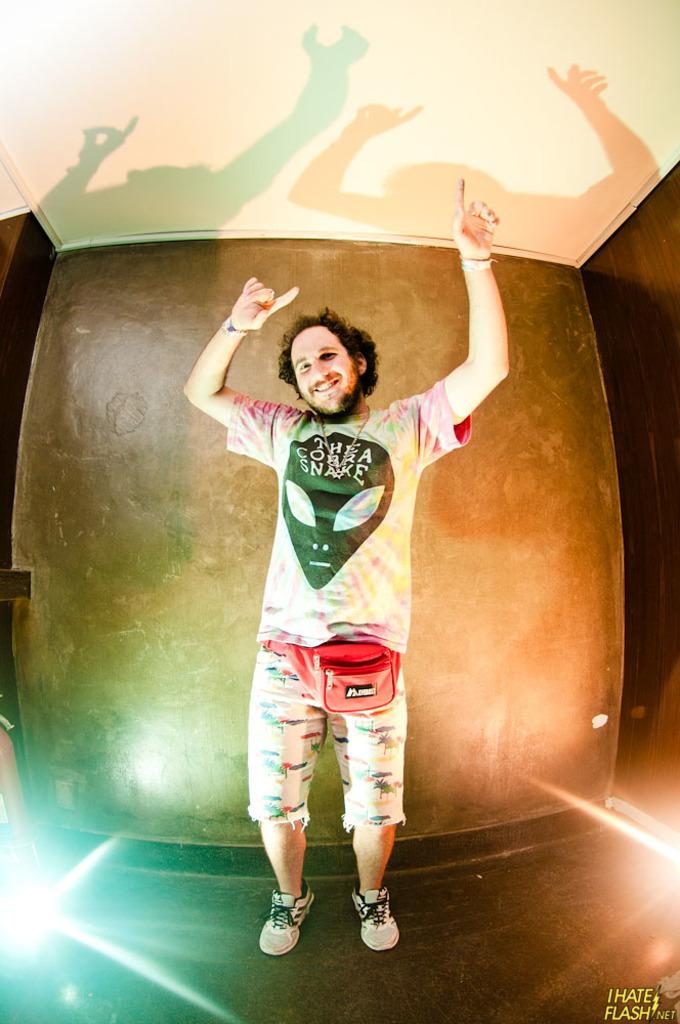What is happening in the image? There is a person in the image, and they are dancing on the floor. What can be seen behind the person? There is a wall behind the person. What is visible at the top of the image? The ceiling is visible at the top of the image. What type of water can be seen in the image? There is no water present in the image. Is there a goat in the image? No, there is no goat in the image. 